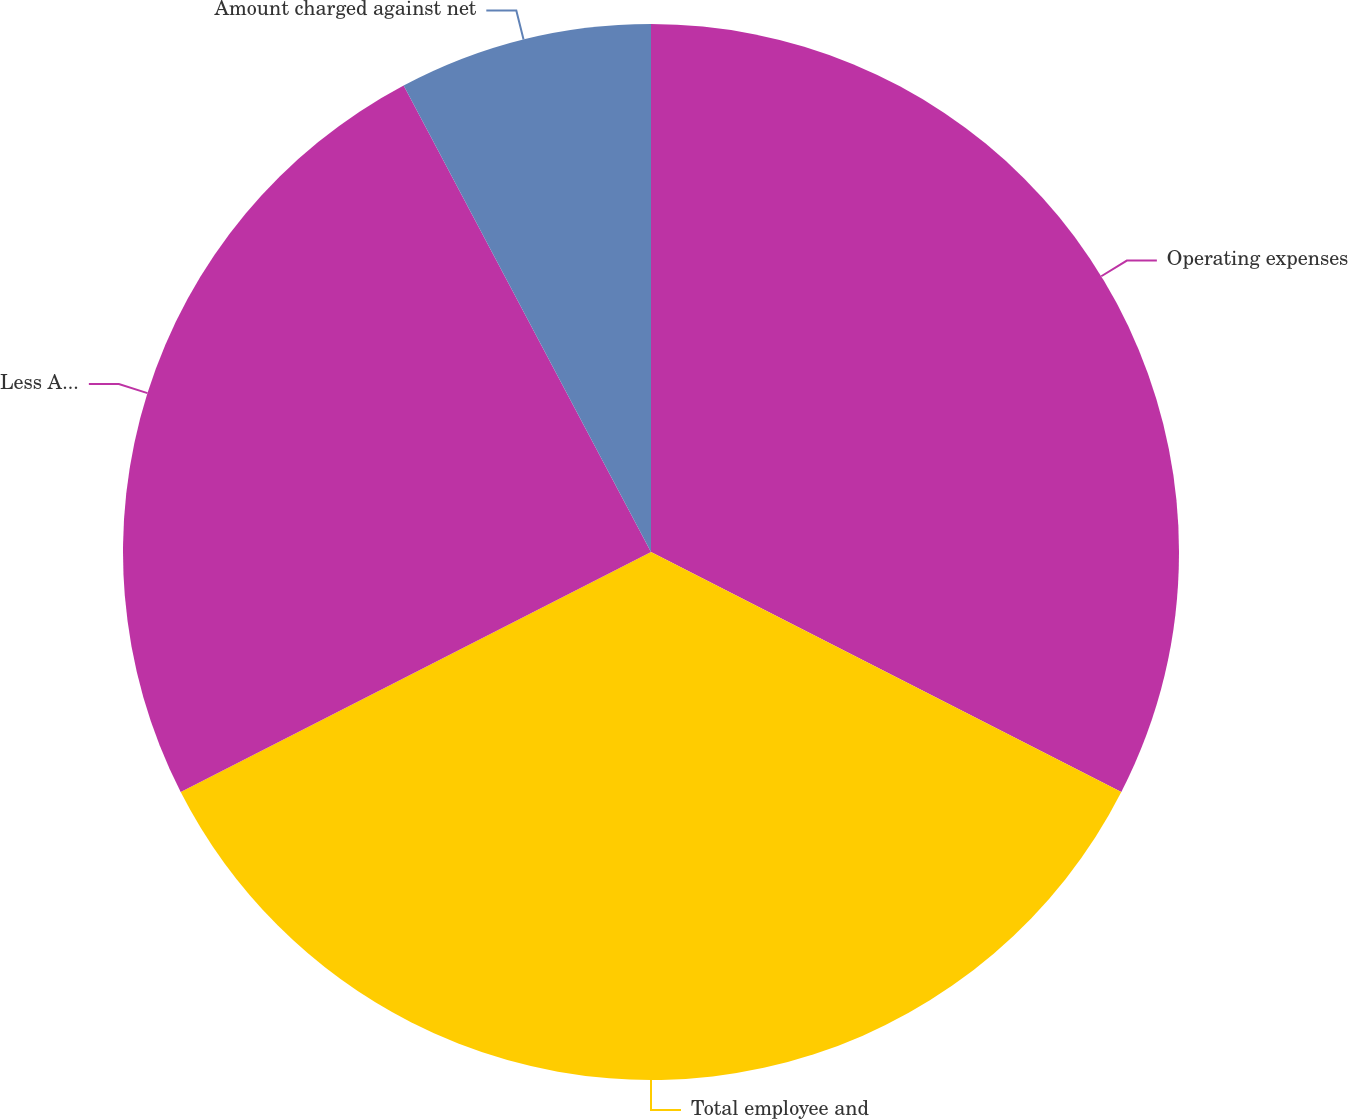<chart> <loc_0><loc_0><loc_500><loc_500><pie_chart><fcel>Operating expenses<fcel>Total employee and<fcel>Less Amount of income tax<fcel>Amount charged against net<nl><fcel>32.51%<fcel>34.98%<fcel>24.75%<fcel>7.76%<nl></chart> 